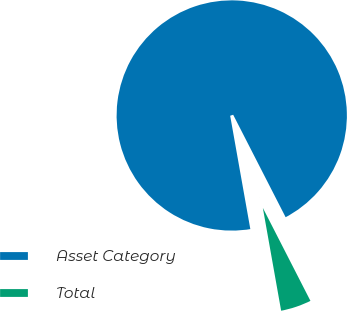Convert chart to OTSL. <chart><loc_0><loc_0><loc_500><loc_500><pie_chart><fcel>Asset Category<fcel>Total<nl><fcel>95.27%<fcel>4.73%<nl></chart> 